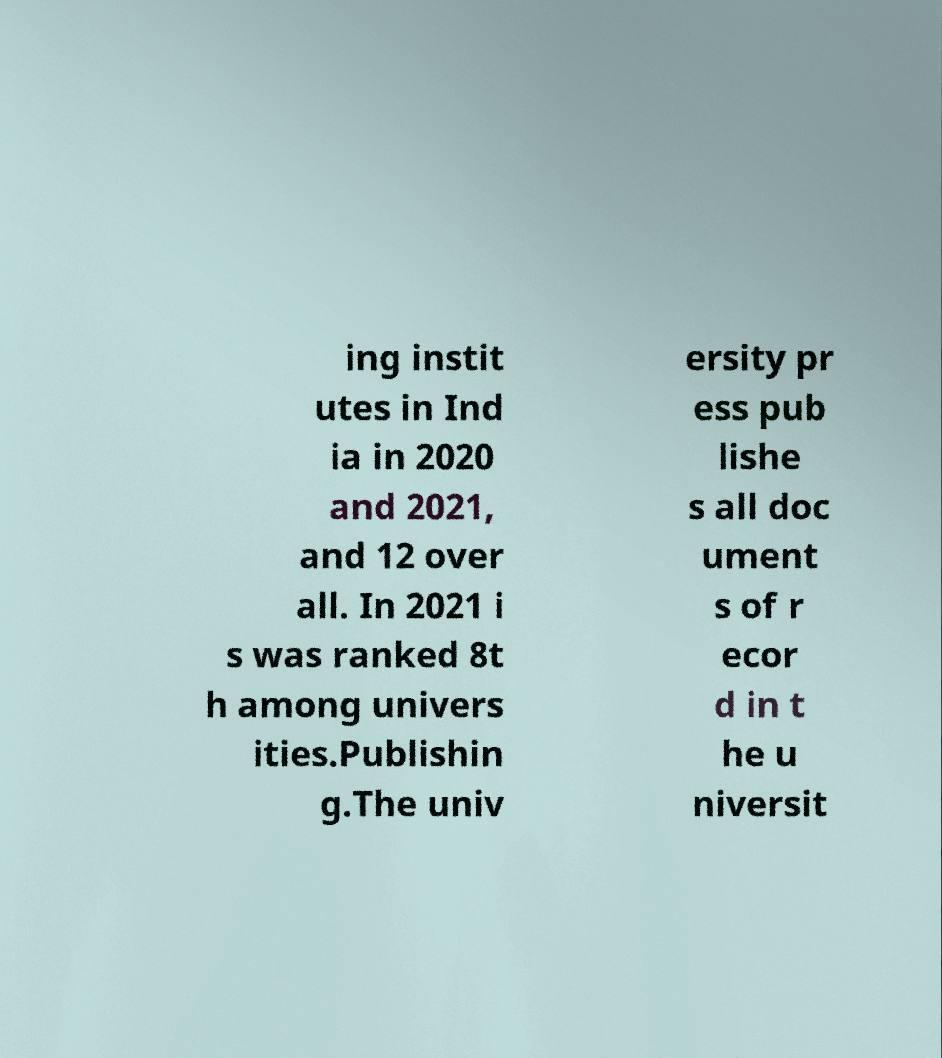There's text embedded in this image that I need extracted. Can you transcribe it verbatim? ing instit utes in Ind ia in 2020 and 2021, and 12 over all. In 2021 i s was ranked 8t h among univers ities.Publishin g.The univ ersity pr ess pub lishe s all doc ument s of r ecor d in t he u niversit 